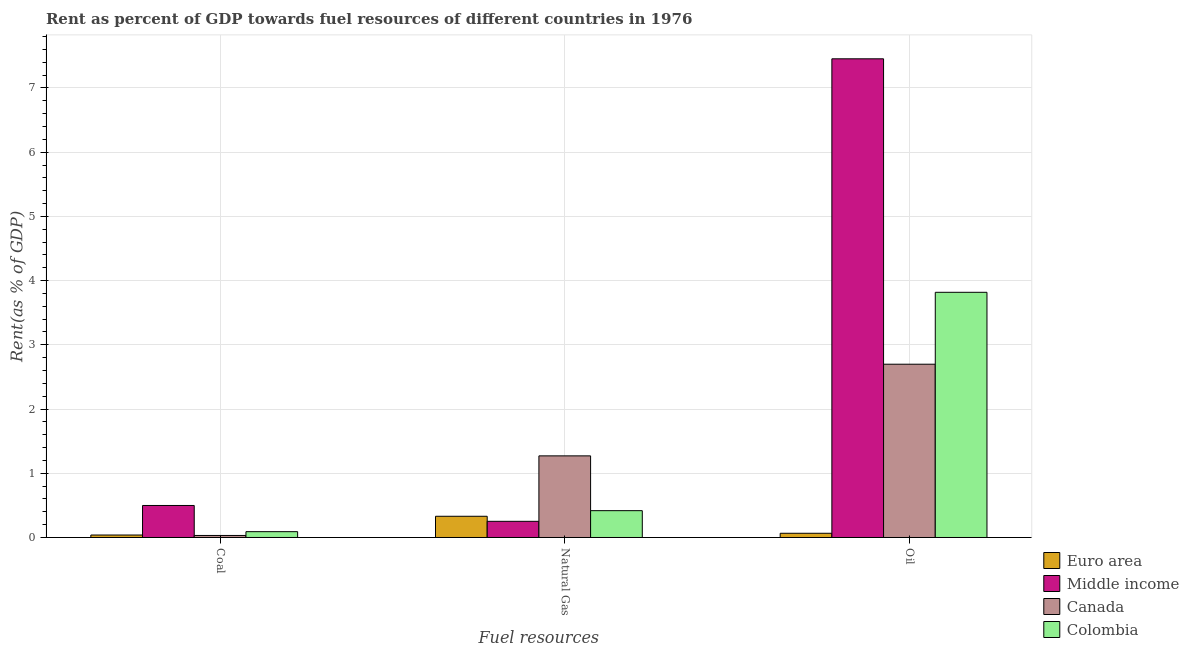How many groups of bars are there?
Your answer should be very brief. 3. Are the number of bars per tick equal to the number of legend labels?
Make the answer very short. Yes. Are the number of bars on each tick of the X-axis equal?
Keep it short and to the point. Yes. What is the label of the 1st group of bars from the left?
Ensure brevity in your answer.  Coal. What is the rent towards oil in Canada?
Give a very brief answer. 2.7. Across all countries, what is the maximum rent towards oil?
Your response must be concise. 7.45. Across all countries, what is the minimum rent towards natural gas?
Offer a terse response. 0.25. In which country was the rent towards oil maximum?
Offer a terse response. Middle income. What is the total rent towards natural gas in the graph?
Offer a very short reply. 2.27. What is the difference between the rent towards coal in Canada and that in Middle income?
Your response must be concise. -0.47. What is the difference between the rent towards oil in Colombia and the rent towards coal in Middle income?
Your answer should be compact. 3.32. What is the average rent towards natural gas per country?
Offer a very short reply. 0.57. What is the difference between the rent towards coal and rent towards oil in Canada?
Your response must be concise. -2.67. In how many countries, is the rent towards oil greater than 5.4 %?
Provide a short and direct response. 1. What is the ratio of the rent towards coal in Middle income to that in Colombia?
Provide a succinct answer. 5.5. Is the rent towards natural gas in Colombia less than that in Middle income?
Your answer should be very brief. No. Is the difference between the rent towards natural gas in Euro area and Colombia greater than the difference between the rent towards oil in Euro area and Colombia?
Provide a succinct answer. Yes. What is the difference between the highest and the second highest rent towards coal?
Ensure brevity in your answer.  0.41. What is the difference between the highest and the lowest rent towards oil?
Provide a succinct answer. 7.39. In how many countries, is the rent towards coal greater than the average rent towards coal taken over all countries?
Offer a very short reply. 1. Is the sum of the rent towards oil in Colombia and Euro area greater than the maximum rent towards natural gas across all countries?
Your answer should be compact. Yes. What does the 3rd bar from the left in Coal represents?
Give a very brief answer. Canada. How many bars are there?
Make the answer very short. 12. Are all the bars in the graph horizontal?
Make the answer very short. No. Are the values on the major ticks of Y-axis written in scientific E-notation?
Your response must be concise. No. Where does the legend appear in the graph?
Your answer should be compact. Bottom right. How are the legend labels stacked?
Your response must be concise. Vertical. What is the title of the graph?
Offer a terse response. Rent as percent of GDP towards fuel resources of different countries in 1976. What is the label or title of the X-axis?
Your response must be concise. Fuel resources. What is the label or title of the Y-axis?
Provide a short and direct response. Rent(as % of GDP). What is the Rent(as % of GDP) in Euro area in Coal?
Provide a succinct answer. 0.04. What is the Rent(as % of GDP) in Middle income in Coal?
Your answer should be very brief. 0.5. What is the Rent(as % of GDP) of Canada in Coal?
Your response must be concise. 0.03. What is the Rent(as % of GDP) in Colombia in Coal?
Your response must be concise. 0.09. What is the Rent(as % of GDP) of Euro area in Natural Gas?
Offer a terse response. 0.33. What is the Rent(as % of GDP) in Middle income in Natural Gas?
Ensure brevity in your answer.  0.25. What is the Rent(as % of GDP) in Canada in Natural Gas?
Provide a short and direct response. 1.27. What is the Rent(as % of GDP) in Colombia in Natural Gas?
Offer a very short reply. 0.42. What is the Rent(as % of GDP) in Euro area in Oil?
Offer a very short reply. 0.07. What is the Rent(as % of GDP) in Middle income in Oil?
Ensure brevity in your answer.  7.45. What is the Rent(as % of GDP) of Canada in Oil?
Provide a succinct answer. 2.7. What is the Rent(as % of GDP) of Colombia in Oil?
Your response must be concise. 3.82. Across all Fuel resources, what is the maximum Rent(as % of GDP) in Euro area?
Ensure brevity in your answer.  0.33. Across all Fuel resources, what is the maximum Rent(as % of GDP) of Middle income?
Provide a short and direct response. 7.45. Across all Fuel resources, what is the maximum Rent(as % of GDP) in Canada?
Your answer should be very brief. 2.7. Across all Fuel resources, what is the maximum Rent(as % of GDP) of Colombia?
Offer a terse response. 3.82. Across all Fuel resources, what is the minimum Rent(as % of GDP) of Euro area?
Keep it short and to the point. 0.04. Across all Fuel resources, what is the minimum Rent(as % of GDP) of Middle income?
Offer a terse response. 0.25. Across all Fuel resources, what is the minimum Rent(as % of GDP) in Canada?
Provide a short and direct response. 0.03. Across all Fuel resources, what is the minimum Rent(as % of GDP) of Colombia?
Provide a succinct answer. 0.09. What is the total Rent(as % of GDP) of Euro area in the graph?
Keep it short and to the point. 0.43. What is the total Rent(as % of GDP) in Middle income in the graph?
Offer a terse response. 8.2. What is the total Rent(as % of GDP) in Canada in the graph?
Make the answer very short. 4. What is the total Rent(as % of GDP) of Colombia in the graph?
Offer a terse response. 4.33. What is the difference between the Rent(as % of GDP) of Euro area in Coal and that in Natural Gas?
Provide a short and direct response. -0.29. What is the difference between the Rent(as % of GDP) in Middle income in Coal and that in Natural Gas?
Offer a terse response. 0.25. What is the difference between the Rent(as % of GDP) in Canada in Coal and that in Natural Gas?
Ensure brevity in your answer.  -1.24. What is the difference between the Rent(as % of GDP) in Colombia in Coal and that in Natural Gas?
Ensure brevity in your answer.  -0.33. What is the difference between the Rent(as % of GDP) in Euro area in Coal and that in Oil?
Give a very brief answer. -0.03. What is the difference between the Rent(as % of GDP) in Middle income in Coal and that in Oil?
Provide a short and direct response. -6.96. What is the difference between the Rent(as % of GDP) of Canada in Coal and that in Oil?
Give a very brief answer. -2.67. What is the difference between the Rent(as % of GDP) in Colombia in Coal and that in Oil?
Keep it short and to the point. -3.73. What is the difference between the Rent(as % of GDP) of Euro area in Natural Gas and that in Oil?
Offer a very short reply. 0.26. What is the difference between the Rent(as % of GDP) of Middle income in Natural Gas and that in Oil?
Keep it short and to the point. -7.2. What is the difference between the Rent(as % of GDP) of Canada in Natural Gas and that in Oil?
Make the answer very short. -1.43. What is the difference between the Rent(as % of GDP) in Colombia in Natural Gas and that in Oil?
Keep it short and to the point. -3.4. What is the difference between the Rent(as % of GDP) of Euro area in Coal and the Rent(as % of GDP) of Middle income in Natural Gas?
Offer a terse response. -0.21. What is the difference between the Rent(as % of GDP) of Euro area in Coal and the Rent(as % of GDP) of Canada in Natural Gas?
Your response must be concise. -1.23. What is the difference between the Rent(as % of GDP) in Euro area in Coal and the Rent(as % of GDP) in Colombia in Natural Gas?
Offer a terse response. -0.38. What is the difference between the Rent(as % of GDP) of Middle income in Coal and the Rent(as % of GDP) of Canada in Natural Gas?
Offer a very short reply. -0.77. What is the difference between the Rent(as % of GDP) of Middle income in Coal and the Rent(as % of GDP) of Colombia in Natural Gas?
Ensure brevity in your answer.  0.08. What is the difference between the Rent(as % of GDP) of Canada in Coal and the Rent(as % of GDP) of Colombia in Natural Gas?
Give a very brief answer. -0.39. What is the difference between the Rent(as % of GDP) in Euro area in Coal and the Rent(as % of GDP) in Middle income in Oil?
Provide a short and direct response. -7.42. What is the difference between the Rent(as % of GDP) of Euro area in Coal and the Rent(as % of GDP) of Canada in Oil?
Your answer should be compact. -2.66. What is the difference between the Rent(as % of GDP) in Euro area in Coal and the Rent(as % of GDP) in Colombia in Oil?
Offer a very short reply. -3.78. What is the difference between the Rent(as % of GDP) of Middle income in Coal and the Rent(as % of GDP) of Canada in Oil?
Offer a very short reply. -2.2. What is the difference between the Rent(as % of GDP) in Middle income in Coal and the Rent(as % of GDP) in Colombia in Oil?
Your response must be concise. -3.32. What is the difference between the Rent(as % of GDP) in Canada in Coal and the Rent(as % of GDP) in Colombia in Oil?
Provide a succinct answer. -3.79. What is the difference between the Rent(as % of GDP) of Euro area in Natural Gas and the Rent(as % of GDP) of Middle income in Oil?
Give a very brief answer. -7.12. What is the difference between the Rent(as % of GDP) in Euro area in Natural Gas and the Rent(as % of GDP) in Canada in Oil?
Your response must be concise. -2.37. What is the difference between the Rent(as % of GDP) in Euro area in Natural Gas and the Rent(as % of GDP) in Colombia in Oil?
Your response must be concise. -3.49. What is the difference between the Rent(as % of GDP) in Middle income in Natural Gas and the Rent(as % of GDP) in Canada in Oil?
Your answer should be very brief. -2.45. What is the difference between the Rent(as % of GDP) in Middle income in Natural Gas and the Rent(as % of GDP) in Colombia in Oil?
Provide a short and direct response. -3.57. What is the difference between the Rent(as % of GDP) of Canada in Natural Gas and the Rent(as % of GDP) of Colombia in Oil?
Your answer should be very brief. -2.55. What is the average Rent(as % of GDP) in Euro area per Fuel resources?
Provide a succinct answer. 0.14. What is the average Rent(as % of GDP) in Middle income per Fuel resources?
Provide a succinct answer. 2.73. What is the average Rent(as % of GDP) of Canada per Fuel resources?
Your answer should be very brief. 1.33. What is the average Rent(as % of GDP) of Colombia per Fuel resources?
Your response must be concise. 1.44. What is the difference between the Rent(as % of GDP) in Euro area and Rent(as % of GDP) in Middle income in Coal?
Your answer should be compact. -0.46. What is the difference between the Rent(as % of GDP) of Euro area and Rent(as % of GDP) of Canada in Coal?
Offer a very short reply. 0.01. What is the difference between the Rent(as % of GDP) of Euro area and Rent(as % of GDP) of Colombia in Coal?
Make the answer very short. -0.05. What is the difference between the Rent(as % of GDP) of Middle income and Rent(as % of GDP) of Canada in Coal?
Provide a short and direct response. 0.47. What is the difference between the Rent(as % of GDP) in Middle income and Rent(as % of GDP) in Colombia in Coal?
Ensure brevity in your answer.  0.41. What is the difference between the Rent(as % of GDP) in Canada and Rent(as % of GDP) in Colombia in Coal?
Ensure brevity in your answer.  -0.06. What is the difference between the Rent(as % of GDP) of Euro area and Rent(as % of GDP) of Middle income in Natural Gas?
Your answer should be very brief. 0.08. What is the difference between the Rent(as % of GDP) of Euro area and Rent(as % of GDP) of Canada in Natural Gas?
Give a very brief answer. -0.94. What is the difference between the Rent(as % of GDP) of Euro area and Rent(as % of GDP) of Colombia in Natural Gas?
Provide a short and direct response. -0.09. What is the difference between the Rent(as % of GDP) of Middle income and Rent(as % of GDP) of Canada in Natural Gas?
Your response must be concise. -1.02. What is the difference between the Rent(as % of GDP) of Middle income and Rent(as % of GDP) of Colombia in Natural Gas?
Give a very brief answer. -0.17. What is the difference between the Rent(as % of GDP) in Canada and Rent(as % of GDP) in Colombia in Natural Gas?
Give a very brief answer. 0.85. What is the difference between the Rent(as % of GDP) of Euro area and Rent(as % of GDP) of Middle income in Oil?
Your answer should be compact. -7.39. What is the difference between the Rent(as % of GDP) in Euro area and Rent(as % of GDP) in Canada in Oil?
Keep it short and to the point. -2.63. What is the difference between the Rent(as % of GDP) of Euro area and Rent(as % of GDP) of Colombia in Oil?
Provide a short and direct response. -3.75. What is the difference between the Rent(as % of GDP) of Middle income and Rent(as % of GDP) of Canada in Oil?
Ensure brevity in your answer.  4.76. What is the difference between the Rent(as % of GDP) in Middle income and Rent(as % of GDP) in Colombia in Oil?
Offer a terse response. 3.64. What is the difference between the Rent(as % of GDP) in Canada and Rent(as % of GDP) in Colombia in Oil?
Provide a succinct answer. -1.12. What is the ratio of the Rent(as % of GDP) of Euro area in Coal to that in Natural Gas?
Offer a terse response. 0.12. What is the ratio of the Rent(as % of GDP) in Middle income in Coal to that in Natural Gas?
Offer a terse response. 1.98. What is the ratio of the Rent(as % of GDP) of Canada in Coal to that in Natural Gas?
Give a very brief answer. 0.02. What is the ratio of the Rent(as % of GDP) in Colombia in Coal to that in Natural Gas?
Offer a very short reply. 0.22. What is the ratio of the Rent(as % of GDP) in Euro area in Coal to that in Oil?
Make the answer very short. 0.58. What is the ratio of the Rent(as % of GDP) in Middle income in Coal to that in Oil?
Your answer should be very brief. 0.07. What is the ratio of the Rent(as % of GDP) of Canada in Coal to that in Oil?
Your response must be concise. 0.01. What is the ratio of the Rent(as % of GDP) of Colombia in Coal to that in Oil?
Provide a succinct answer. 0.02. What is the ratio of the Rent(as % of GDP) in Euro area in Natural Gas to that in Oil?
Ensure brevity in your answer.  5.03. What is the ratio of the Rent(as % of GDP) of Middle income in Natural Gas to that in Oil?
Keep it short and to the point. 0.03. What is the ratio of the Rent(as % of GDP) in Canada in Natural Gas to that in Oil?
Provide a succinct answer. 0.47. What is the ratio of the Rent(as % of GDP) of Colombia in Natural Gas to that in Oil?
Your answer should be compact. 0.11. What is the difference between the highest and the second highest Rent(as % of GDP) of Euro area?
Your answer should be compact. 0.26. What is the difference between the highest and the second highest Rent(as % of GDP) in Middle income?
Provide a succinct answer. 6.96. What is the difference between the highest and the second highest Rent(as % of GDP) in Canada?
Your answer should be very brief. 1.43. What is the difference between the highest and the second highest Rent(as % of GDP) of Colombia?
Keep it short and to the point. 3.4. What is the difference between the highest and the lowest Rent(as % of GDP) of Euro area?
Make the answer very short. 0.29. What is the difference between the highest and the lowest Rent(as % of GDP) of Middle income?
Your answer should be very brief. 7.2. What is the difference between the highest and the lowest Rent(as % of GDP) in Canada?
Provide a succinct answer. 2.67. What is the difference between the highest and the lowest Rent(as % of GDP) of Colombia?
Give a very brief answer. 3.73. 